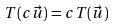Convert formula to latex. <formula><loc_0><loc_0><loc_500><loc_500>T ( c \vec { u } ) = c T ( \vec { u } )</formula> 